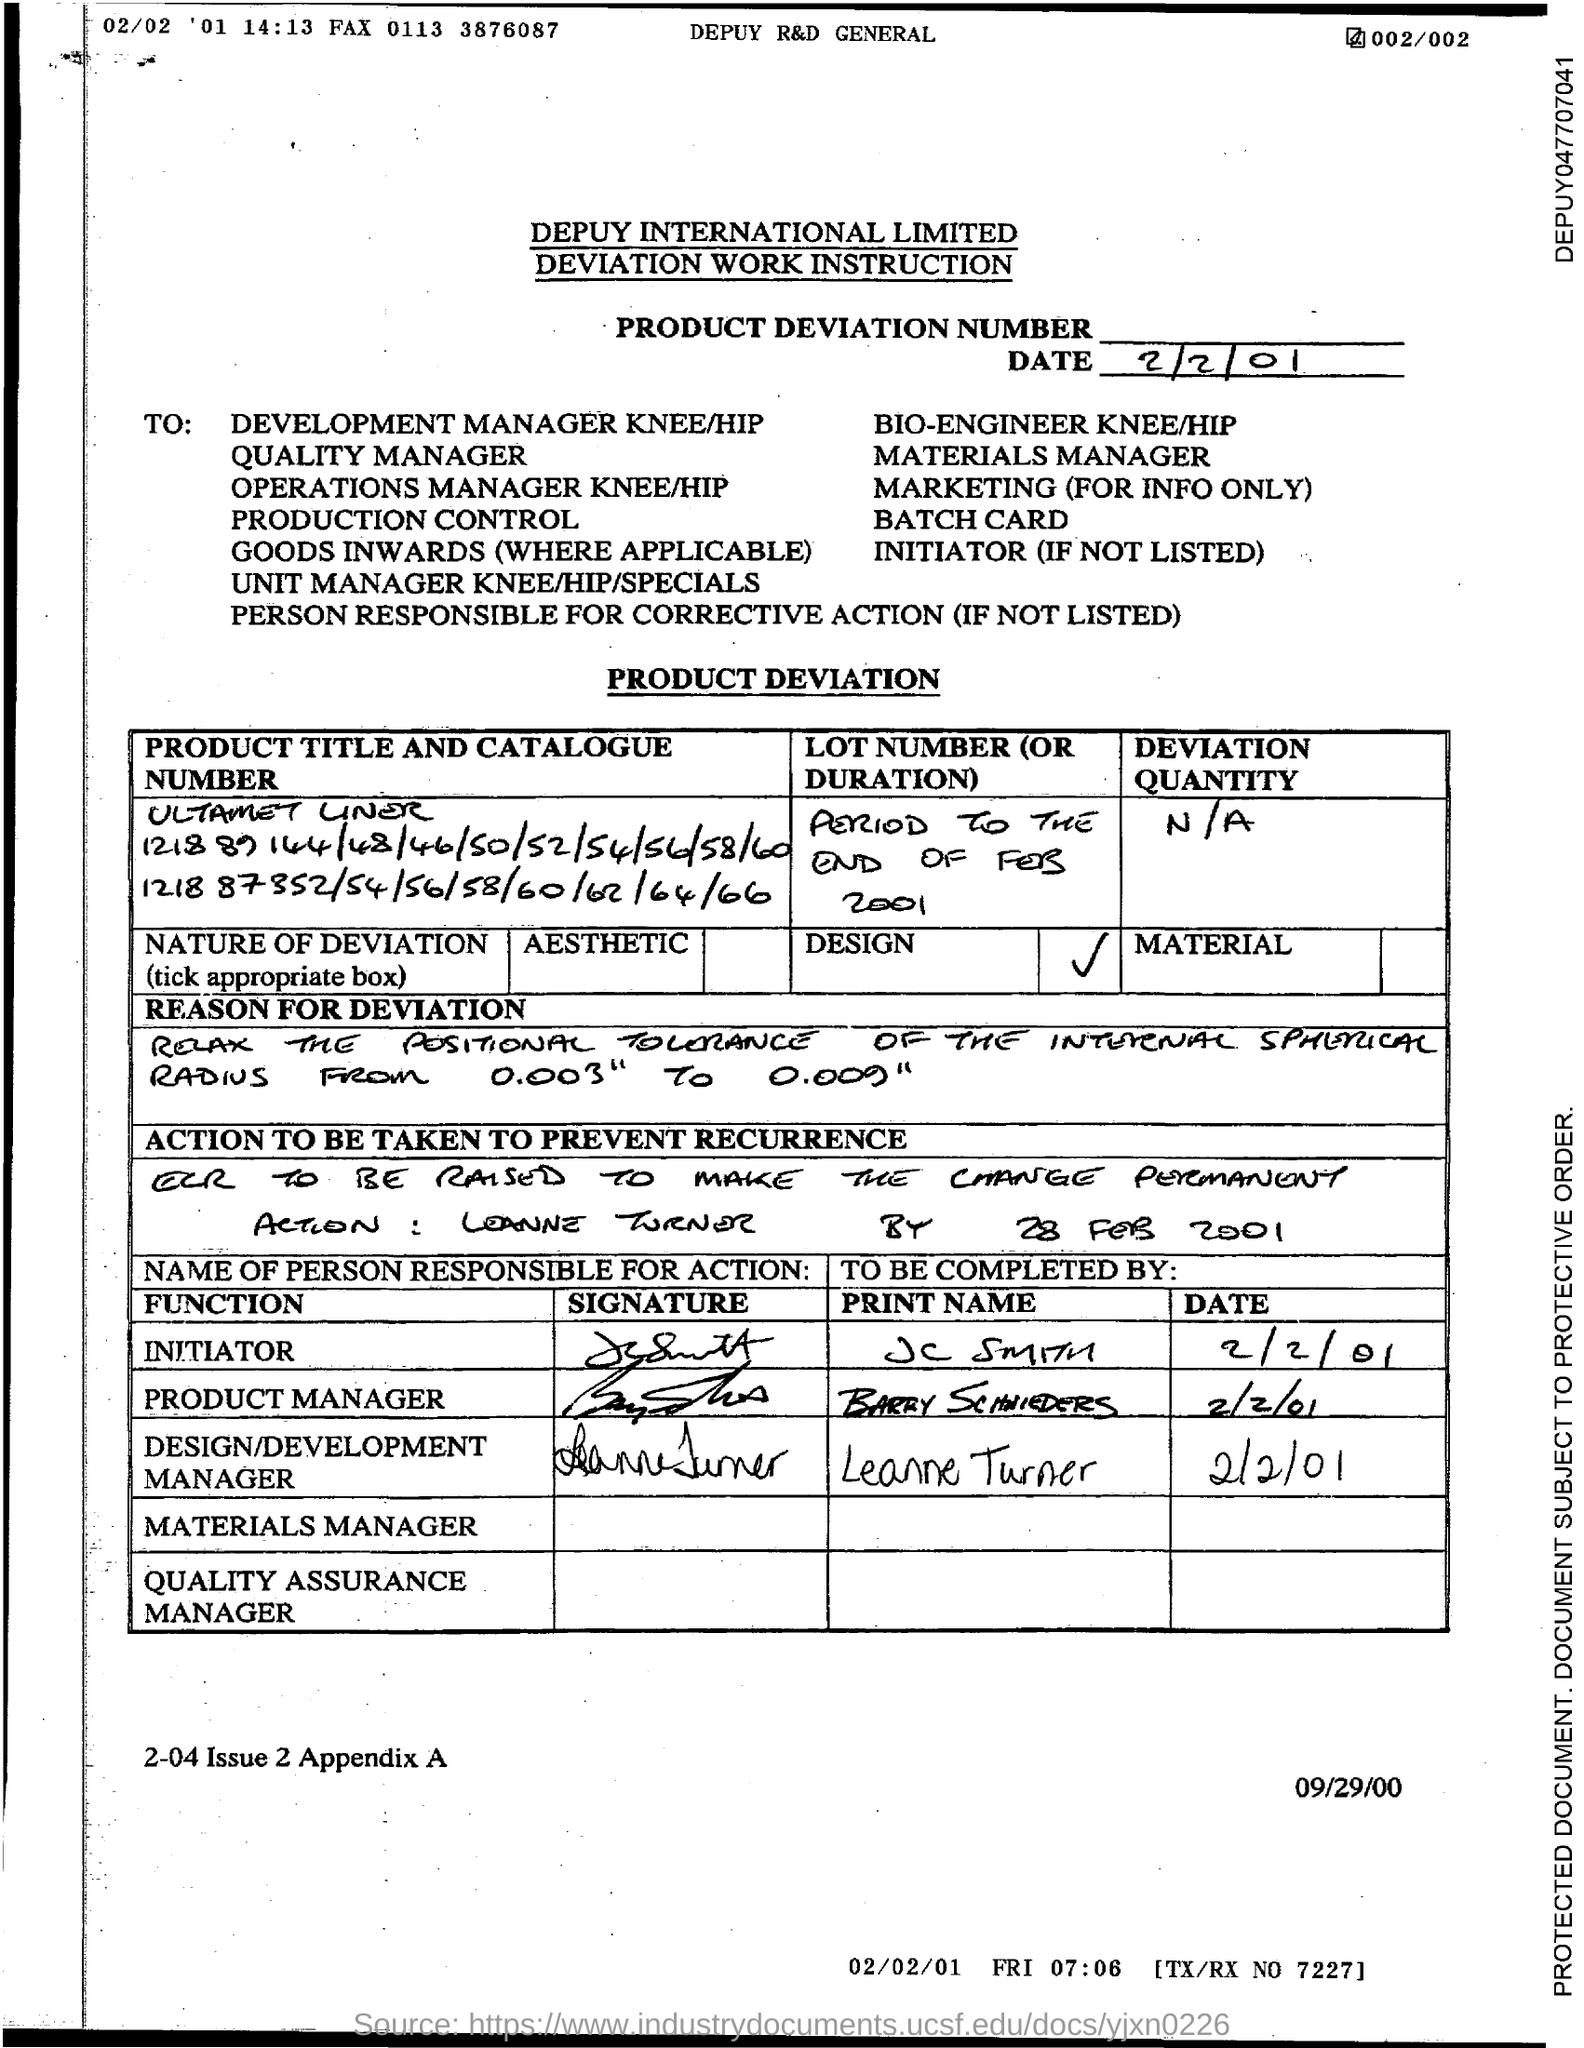Mention a couple of crucial points in this snapshot. The name of the design/development manager is Leanne Turner. 